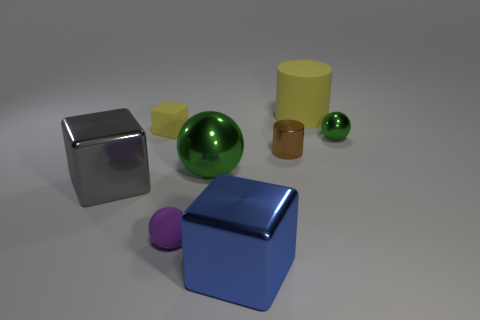Subtract all metal blocks. How many blocks are left? 1 Subtract all purple cylinders. How many green spheres are left? 2 Subtract 1 spheres. How many spheres are left? 2 Add 1 big purple shiny spheres. How many objects exist? 9 Subtract all cylinders. How many objects are left? 6 Subtract all big cyan matte spheres. Subtract all tiny green objects. How many objects are left? 7 Add 2 small brown shiny cylinders. How many small brown shiny cylinders are left? 3 Add 3 large cylinders. How many large cylinders exist? 4 Subtract 0 red balls. How many objects are left? 8 